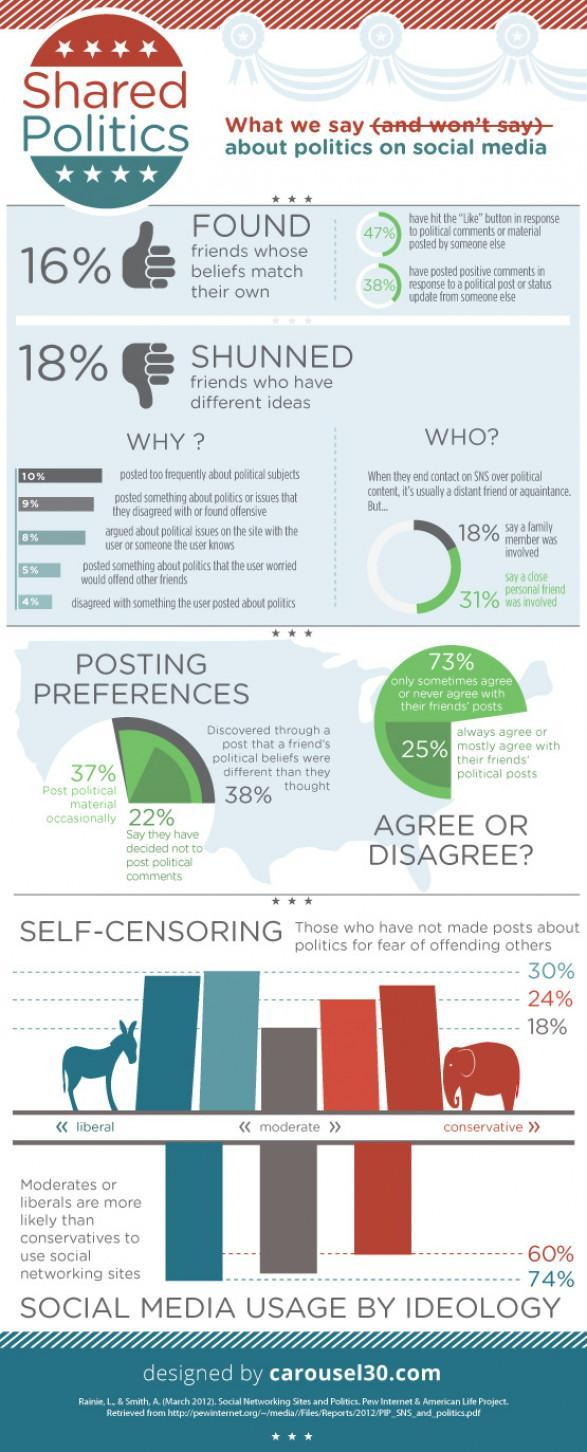Who are the "most" likely to use social networking sites, moderates or liberals?
Answer the question with a short phrase. Liberals What percentage of people discovered friends who had similar political beliefs? 16% Which animal is used to represent liberals - cow, donkey or elephant? Donkey What percentage of people fail to agree or occasionally agree with their friends posts? 73% Which are the three political groups by ideology? Liberals, moderates, conservatives Who are the least likely to use social networking sites? Conservatives What is the % usage of social network sites by conservatives? 60% What percentage of "moderates",  have not made political posts for the fear of being offensive? 18% What percentage of people do not post political comments? 22% What is the % usage of social network sites by liberals? 74% What percentage of people found that their friends do not share similar political beliefs from their posts? 38% What percentage of people post political material occasionally? 37% What percentage of people mostly agree with their friends posts? 25% 